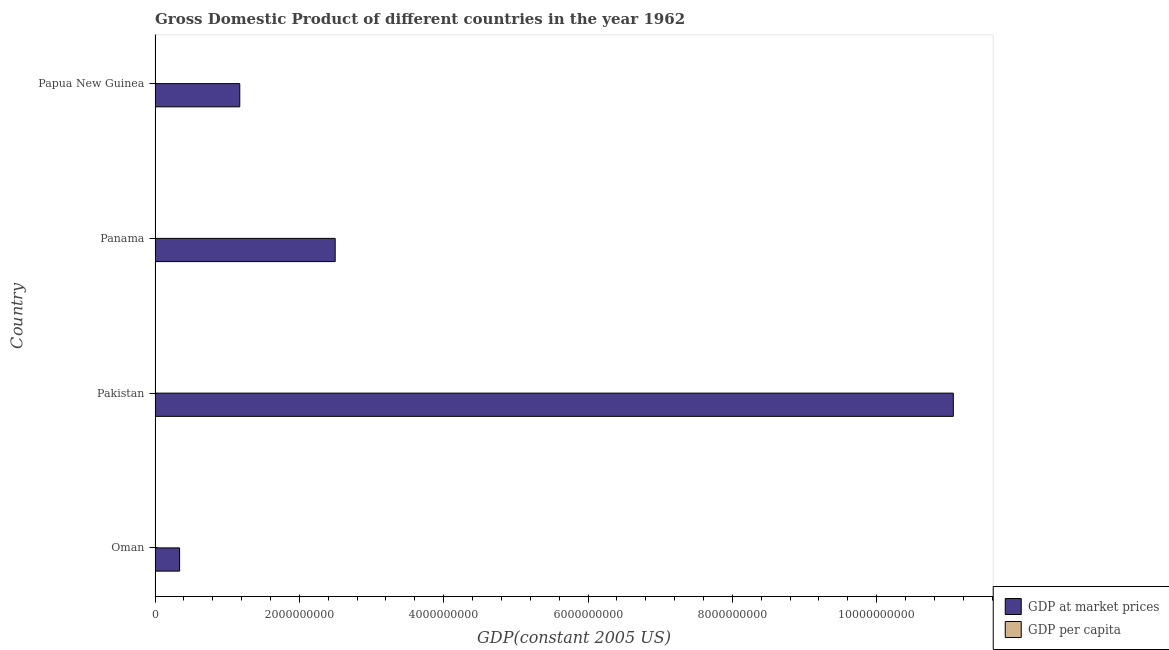How many groups of bars are there?
Give a very brief answer. 4. Are the number of bars per tick equal to the number of legend labels?
Your answer should be compact. Yes. How many bars are there on the 1st tick from the bottom?
Offer a terse response. 2. What is the label of the 3rd group of bars from the top?
Keep it short and to the point. Pakistan. What is the gdp per capita in Papua New Guinea?
Your answer should be compact. 576.26. Across all countries, what is the maximum gdp per capita?
Your response must be concise. 2076.28. Across all countries, what is the minimum gdp per capita?
Your answer should be very brief. 234.77. In which country was the gdp per capita maximum?
Your answer should be very brief. Panama. In which country was the gdp per capita minimum?
Offer a terse response. Pakistan. What is the total gdp per capita in the graph?
Ensure brevity in your answer.  3474.92. What is the difference between the gdp per capita in Oman and that in Papua New Guinea?
Give a very brief answer. 11.36. What is the difference between the gdp per capita in Papua New Guinea and the gdp at market prices in Pakistan?
Make the answer very short. -1.11e+1. What is the average gdp at market prices per country?
Provide a succinct answer. 3.77e+09. What is the difference between the gdp at market prices and gdp per capita in Pakistan?
Your response must be concise. 1.11e+1. What is the ratio of the gdp at market prices in Pakistan to that in Panama?
Provide a succinct answer. 4.43. Is the difference between the gdp at market prices in Panama and Papua New Guinea greater than the difference between the gdp per capita in Panama and Papua New Guinea?
Provide a succinct answer. Yes. What is the difference between the highest and the second highest gdp per capita?
Your answer should be compact. 1488.67. What is the difference between the highest and the lowest gdp at market prices?
Provide a succinct answer. 1.07e+1. In how many countries, is the gdp per capita greater than the average gdp per capita taken over all countries?
Your answer should be very brief. 1. What does the 1st bar from the top in Papua New Guinea represents?
Offer a terse response. GDP per capita. What does the 2nd bar from the bottom in Papua New Guinea represents?
Give a very brief answer. GDP per capita. Are all the bars in the graph horizontal?
Keep it short and to the point. Yes. How many countries are there in the graph?
Provide a succinct answer. 4. What is the difference between two consecutive major ticks on the X-axis?
Make the answer very short. 2.00e+09. Are the values on the major ticks of X-axis written in scientific E-notation?
Offer a very short reply. No. Does the graph contain any zero values?
Your answer should be very brief. No. What is the title of the graph?
Offer a terse response. Gross Domestic Product of different countries in the year 1962. Does "Nitrous oxide" appear as one of the legend labels in the graph?
Ensure brevity in your answer.  No. What is the label or title of the X-axis?
Your answer should be compact. GDP(constant 2005 US). What is the GDP(constant 2005 US) in GDP at market prices in Oman?
Offer a very short reply. 3.40e+08. What is the GDP(constant 2005 US) of GDP per capita in Oman?
Offer a very short reply. 587.62. What is the GDP(constant 2005 US) in GDP at market prices in Pakistan?
Keep it short and to the point. 1.11e+1. What is the GDP(constant 2005 US) of GDP per capita in Pakistan?
Your response must be concise. 234.77. What is the GDP(constant 2005 US) in GDP at market prices in Panama?
Give a very brief answer. 2.50e+09. What is the GDP(constant 2005 US) of GDP per capita in Panama?
Provide a short and direct response. 2076.28. What is the GDP(constant 2005 US) of GDP at market prices in Papua New Guinea?
Your answer should be very brief. 1.17e+09. What is the GDP(constant 2005 US) of GDP per capita in Papua New Guinea?
Give a very brief answer. 576.26. Across all countries, what is the maximum GDP(constant 2005 US) of GDP at market prices?
Provide a short and direct response. 1.11e+1. Across all countries, what is the maximum GDP(constant 2005 US) of GDP per capita?
Offer a very short reply. 2076.28. Across all countries, what is the minimum GDP(constant 2005 US) of GDP at market prices?
Your response must be concise. 3.40e+08. Across all countries, what is the minimum GDP(constant 2005 US) in GDP per capita?
Provide a short and direct response. 234.77. What is the total GDP(constant 2005 US) of GDP at market prices in the graph?
Your answer should be very brief. 1.51e+1. What is the total GDP(constant 2005 US) of GDP per capita in the graph?
Provide a succinct answer. 3474.92. What is the difference between the GDP(constant 2005 US) of GDP at market prices in Oman and that in Pakistan?
Keep it short and to the point. -1.07e+1. What is the difference between the GDP(constant 2005 US) in GDP per capita in Oman and that in Pakistan?
Make the answer very short. 352.85. What is the difference between the GDP(constant 2005 US) of GDP at market prices in Oman and that in Panama?
Provide a succinct answer. -2.16e+09. What is the difference between the GDP(constant 2005 US) of GDP per capita in Oman and that in Panama?
Offer a terse response. -1488.67. What is the difference between the GDP(constant 2005 US) in GDP at market prices in Oman and that in Papua New Guinea?
Your response must be concise. -8.34e+08. What is the difference between the GDP(constant 2005 US) of GDP per capita in Oman and that in Papua New Guinea?
Make the answer very short. 11.36. What is the difference between the GDP(constant 2005 US) of GDP at market prices in Pakistan and that in Panama?
Your response must be concise. 8.57e+09. What is the difference between the GDP(constant 2005 US) of GDP per capita in Pakistan and that in Panama?
Offer a very short reply. -1841.51. What is the difference between the GDP(constant 2005 US) of GDP at market prices in Pakistan and that in Papua New Guinea?
Your answer should be compact. 9.89e+09. What is the difference between the GDP(constant 2005 US) of GDP per capita in Pakistan and that in Papua New Guinea?
Offer a very short reply. -341.49. What is the difference between the GDP(constant 2005 US) of GDP at market prices in Panama and that in Papua New Guinea?
Your answer should be compact. 1.32e+09. What is the difference between the GDP(constant 2005 US) in GDP per capita in Panama and that in Papua New Guinea?
Offer a very short reply. 1500.03. What is the difference between the GDP(constant 2005 US) of GDP at market prices in Oman and the GDP(constant 2005 US) of GDP per capita in Pakistan?
Your answer should be very brief. 3.40e+08. What is the difference between the GDP(constant 2005 US) of GDP at market prices in Oman and the GDP(constant 2005 US) of GDP per capita in Panama?
Your response must be concise. 3.40e+08. What is the difference between the GDP(constant 2005 US) in GDP at market prices in Oman and the GDP(constant 2005 US) in GDP per capita in Papua New Guinea?
Provide a short and direct response. 3.40e+08. What is the difference between the GDP(constant 2005 US) of GDP at market prices in Pakistan and the GDP(constant 2005 US) of GDP per capita in Panama?
Keep it short and to the point. 1.11e+1. What is the difference between the GDP(constant 2005 US) in GDP at market prices in Pakistan and the GDP(constant 2005 US) in GDP per capita in Papua New Guinea?
Offer a very short reply. 1.11e+1. What is the difference between the GDP(constant 2005 US) of GDP at market prices in Panama and the GDP(constant 2005 US) of GDP per capita in Papua New Guinea?
Offer a very short reply. 2.50e+09. What is the average GDP(constant 2005 US) in GDP at market prices per country?
Your response must be concise. 3.77e+09. What is the average GDP(constant 2005 US) of GDP per capita per country?
Provide a succinct answer. 868.73. What is the difference between the GDP(constant 2005 US) in GDP at market prices and GDP(constant 2005 US) in GDP per capita in Oman?
Give a very brief answer. 3.40e+08. What is the difference between the GDP(constant 2005 US) of GDP at market prices and GDP(constant 2005 US) of GDP per capita in Pakistan?
Provide a short and direct response. 1.11e+1. What is the difference between the GDP(constant 2005 US) in GDP at market prices and GDP(constant 2005 US) in GDP per capita in Panama?
Give a very brief answer. 2.50e+09. What is the difference between the GDP(constant 2005 US) of GDP at market prices and GDP(constant 2005 US) of GDP per capita in Papua New Guinea?
Ensure brevity in your answer.  1.17e+09. What is the ratio of the GDP(constant 2005 US) of GDP at market prices in Oman to that in Pakistan?
Your answer should be very brief. 0.03. What is the ratio of the GDP(constant 2005 US) of GDP per capita in Oman to that in Pakistan?
Give a very brief answer. 2.5. What is the ratio of the GDP(constant 2005 US) in GDP at market prices in Oman to that in Panama?
Offer a very short reply. 0.14. What is the ratio of the GDP(constant 2005 US) of GDP per capita in Oman to that in Panama?
Offer a terse response. 0.28. What is the ratio of the GDP(constant 2005 US) in GDP at market prices in Oman to that in Papua New Guinea?
Keep it short and to the point. 0.29. What is the ratio of the GDP(constant 2005 US) of GDP per capita in Oman to that in Papua New Guinea?
Provide a short and direct response. 1.02. What is the ratio of the GDP(constant 2005 US) of GDP at market prices in Pakistan to that in Panama?
Ensure brevity in your answer.  4.43. What is the ratio of the GDP(constant 2005 US) of GDP per capita in Pakistan to that in Panama?
Keep it short and to the point. 0.11. What is the ratio of the GDP(constant 2005 US) of GDP at market prices in Pakistan to that in Papua New Guinea?
Keep it short and to the point. 9.42. What is the ratio of the GDP(constant 2005 US) of GDP per capita in Pakistan to that in Papua New Guinea?
Give a very brief answer. 0.41. What is the ratio of the GDP(constant 2005 US) of GDP at market prices in Panama to that in Papua New Guinea?
Your response must be concise. 2.13. What is the ratio of the GDP(constant 2005 US) in GDP per capita in Panama to that in Papua New Guinea?
Provide a short and direct response. 3.6. What is the difference between the highest and the second highest GDP(constant 2005 US) in GDP at market prices?
Offer a terse response. 8.57e+09. What is the difference between the highest and the second highest GDP(constant 2005 US) in GDP per capita?
Ensure brevity in your answer.  1488.67. What is the difference between the highest and the lowest GDP(constant 2005 US) in GDP at market prices?
Your answer should be very brief. 1.07e+1. What is the difference between the highest and the lowest GDP(constant 2005 US) of GDP per capita?
Your response must be concise. 1841.51. 